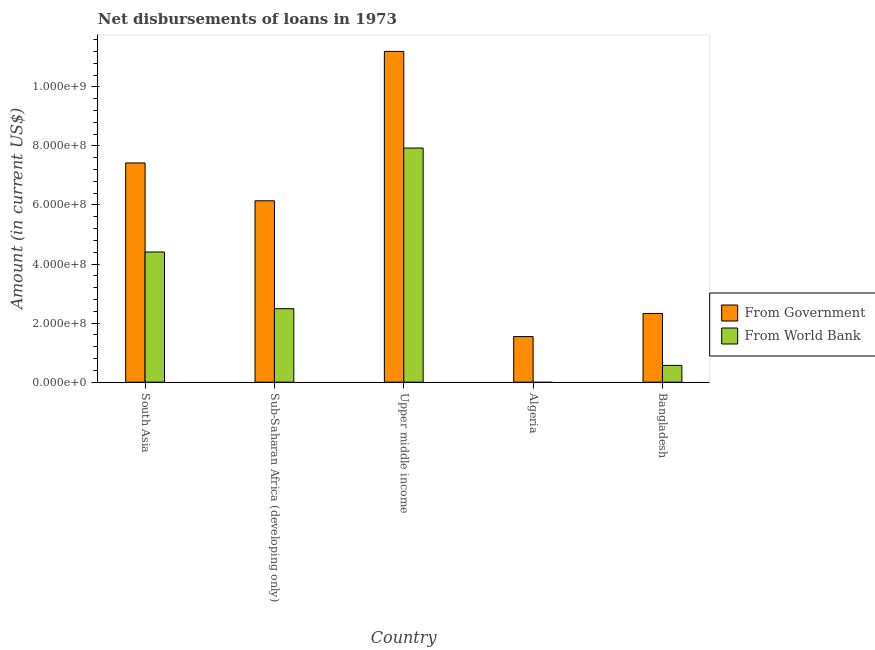How many bars are there on the 2nd tick from the left?
Make the answer very short. 2. What is the label of the 2nd group of bars from the left?
Provide a succinct answer. Sub-Saharan Africa (developing only). In how many cases, is the number of bars for a given country not equal to the number of legend labels?
Offer a very short reply. 1. What is the net disbursements of loan from government in Algeria?
Provide a succinct answer. 1.54e+08. Across all countries, what is the maximum net disbursements of loan from government?
Provide a short and direct response. 1.12e+09. Across all countries, what is the minimum net disbursements of loan from government?
Your response must be concise. 1.54e+08. In which country was the net disbursements of loan from world bank maximum?
Provide a succinct answer. Upper middle income. What is the total net disbursements of loan from world bank in the graph?
Make the answer very short. 1.54e+09. What is the difference between the net disbursements of loan from world bank in Bangladesh and that in Sub-Saharan Africa (developing only)?
Offer a very short reply. -1.92e+08. What is the difference between the net disbursements of loan from world bank in Sub-Saharan Africa (developing only) and the net disbursements of loan from government in Upper middle income?
Your answer should be compact. -8.71e+08. What is the average net disbursements of loan from world bank per country?
Ensure brevity in your answer.  3.08e+08. What is the difference between the net disbursements of loan from world bank and net disbursements of loan from government in South Asia?
Your answer should be compact. -3.02e+08. In how many countries, is the net disbursements of loan from world bank greater than 400000000 US$?
Your response must be concise. 2. What is the ratio of the net disbursements of loan from government in Bangladesh to that in Upper middle income?
Provide a succinct answer. 0.21. Is the net disbursements of loan from world bank in South Asia less than that in Sub-Saharan Africa (developing only)?
Ensure brevity in your answer.  No. Is the difference between the net disbursements of loan from world bank in Bangladesh and South Asia greater than the difference between the net disbursements of loan from government in Bangladesh and South Asia?
Your answer should be compact. Yes. What is the difference between the highest and the second highest net disbursements of loan from world bank?
Offer a very short reply. 3.52e+08. What is the difference between the highest and the lowest net disbursements of loan from world bank?
Provide a short and direct response. 7.93e+08. What is the difference between two consecutive major ticks on the Y-axis?
Give a very brief answer. 2.00e+08. Are the values on the major ticks of Y-axis written in scientific E-notation?
Your response must be concise. Yes. Does the graph contain any zero values?
Give a very brief answer. Yes. Does the graph contain grids?
Give a very brief answer. No. Where does the legend appear in the graph?
Your response must be concise. Center right. How many legend labels are there?
Give a very brief answer. 2. What is the title of the graph?
Keep it short and to the point. Net disbursements of loans in 1973. Does "National Tourists" appear as one of the legend labels in the graph?
Your response must be concise. No. What is the label or title of the X-axis?
Your answer should be compact. Country. What is the label or title of the Y-axis?
Offer a terse response. Amount (in current US$). What is the Amount (in current US$) of From Government in South Asia?
Your response must be concise. 7.42e+08. What is the Amount (in current US$) of From World Bank in South Asia?
Provide a succinct answer. 4.41e+08. What is the Amount (in current US$) of From Government in Sub-Saharan Africa (developing only)?
Ensure brevity in your answer.  6.14e+08. What is the Amount (in current US$) in From World Bank in Sub-Saharan Africa (developing only)?
Your response must be concise. 2.49e+08. What is the Amount (in current US$) in From Government in Upper middle income?
Offer a very short reply. 1.12e+09. What is the Amount (in current US$) of From World Bank in Upper middle income?
Offer a very short reply. 7.93e+08. What is the Amount (in current US$) of From Government in Algeria?
Your answer should be compact. 1.54e+08. What is the Amount (in current US$) in From Government in Bangladesh?
Your answer should be very brief. 2.33e+08. What is the Amount (in current US$) of From World Bank in Bangladesh?
Provide a short and direct response. 5.68e+07. Across all countries, what is the maximum Amount (in current US$) of From Government?
Your answer should be very brief. 1.12e+09. Across all countries, what is the maximum Amount (in current US$) in From World Bank?
Keep it short and to the point. 7.93e+08. Across all countries, what is the minimum Amount (in current US$) of From Government?
Your answer should be compact. 1.54e+08. What is the total Amount (in current US$) in From Government in the graph?
Your answer should be very brief. 2.86e+09. What is the total Amount (in current US$) of From World Bank in the graph?
Offer a very short reply. 1.54e+09. What is the difference between the Amount (in current US$) in From Government in South Asia and that in Sub-Saharan Africa (developing only)?
Your answer should be compact. 1.28e+08. What is the difference between the Amount (in current US$) of From World Bank in South Asia and that in Sub-Saharan Africa (developing only)?
Give a very brief answer. 1.92e+08. What is the difference between the Amount (in current US$) of From Government in South Asia and that in Upper middle income?
Your answer should be compact. -3.78e+08. What is the difference between the Amount (in current US$) in From World Bank in South Asia and that in Upper middle income?
Ensure brevity in your answer.  -3.52e+08. What is the difference between the Amount (in current US$) of From Government in South Asia and that in Algeria?
Give a very brief answer. 5.88e+08. What is the difference between the Amount (in current US$) in From Government in South Asia and that in Bangladesh?
Give a very brief answer. 5.10e+08. What is the difference between the Amount (in current US$) of From World Bank in South Asia and that in Bangladesh?
Make the answer very short. 3.84e+08. What is the difference between the Amount (in current US$) in From Government in Sub-Saharan Africa (developing only) and that in Upper middle income?
Give a very brief answer. -5.06e+08. What is the difference between the Amount (in current US$) of From World Bank in Sub-Saharan Africa (developing only) and that in Upper middle income?
Make the answer very short. -5.44e+08. What is the difference between the Amount (in current US$) in From Government in Sub-Saharan Africa (developing only) and that in Algeria?
Make the answer very short. 4.60e+08. What is the difference between the Amount (in current US$) of From Government in Sub-Saharan Africa (developing only) and that in Bangladesh?
Make the answer very short. 3.82e+08. What is the difference between the Amount (in current US$) of From World Bank in Sub-Saharan Africa (developing only) and that in Bangladesh?
Your answer should be compact. 1.92e+08. What is the difference between the Amount (in current US$) of From Government in Upper middle income and that in Algeria?
Your response must be concise. 9.66e+08. What is the difference between the Amount (in current US$) of From Government in Upper middle income and that in Bangladesh?
Ensure brevity in your answer.  8.87e+08. What is the difference between the Amount (in current US$) of From World Bank in Upper middle income and that in Bangladesh?
Provide a short and direct response. 7.36e+08. What is the difference between the Amount (in current US$) in From Government in Algeria and that in Bangladesh?
Offer a very short reply. -7.82e+07. What is the difference between the Amount (in current US$) of From Government in South Asia and the Amount (in current US$) of From World Bank in Sub-Saharan Africa (developing only)?
Provide a short and direct response. 4.93e+08. What is the difference between the Amount (in current US$) in From Government in South Asia and the Amount (in current US$) in From World Bank in Upper middle income?
Your answer should be very brief. -5.05e+07. What is the difference between the Amount (in current US$) in From Government in South Asia and the Amount (in current US$) in From World Bank in Bangladesh?
Provide a short and direct response. 6.85e+08. What is the difference between the Amount (in current US$) of From Government in Sub-Saharan Africa (developing only) and the Amount (in current US$) of From World Bank in Upper middle income?
Offer a terse response. -1.79e+08. What is the difference between the Amount (in current US$) in From Government in Sub-Saharan Africa (developing only) and the Amount (in current US$) in From World Bank in Bangladesh?
Provide a short and direct response. 5.57e+08. What is the difference between the Amount (in current US$) in From Government in Upper middle income and the Amount (in current US$) in From World Bank in Bangladesh?
Your response must be concise. 1.06e+09. What is the difference between the Amount (in current US$) in From Government in Algeria and the Amount (in current US$) in From World Bank in Bangladesh?
Your answer should be compact. 9.75e+07. What is the average Amount (in current US$) in From Government per country?
Offer a very short reply. 5.73e+08. What is the average Amount (in current US$) of From World Bank per country?
Keep it short and to the point. 3.08e+08. What is the difference between the Amount (in current US$) of From Government and Amount (in current US$) of From World Bank in South Asia?
Make the answer very short. 3.02e+08. What is the difference between the Amount (in current US$) of From Government and Amount (in current US$) of From World Bank in Sub-Saharan Africa (developing only)?
Keep it short and to the point. 3.65e+08. What is the difference between the Amount (in current US$) of From Government and Amount (in current US$) of From World Bank in Upper middle income?
Your answer should be compact. 3.27e+08. What is the difference between the Amount (in current US$) in From Government and Amount (in current US$) in From World Bank in Bangladesh?
Keep it short and to the point. 1.76e+08. What is the ratio of the Amount (in current US$) of From Government in South Asia to that in Sub-Saharan Africa (developing only)?
Ensure brevity in your answer.  1.21. What is the ratio of the Amount (in current US$) in From World Bank in South Asia to that in Sub-Saharan Africa (developing only)?
Offer a terse response. 1.77. What is the ratio of the Amount (in current US$) of From Government in South Asia to that in Upper middle income?
Provide a succinct answer. 0.66. What is the ratio of the Amount (in current US$) in From World Bank in South Asia to that in Upper middle income?
Your answer should be compact. 0.56. What is the ratio of the Amount (in current US$) in From Government in South Asia to that in Algeria?
Offer a very short reply. 4.81. What is the ratio of the Amount (in current US$) in From Government in South Asia to that in Bangladesh?
Give a very brief answer. 3.19. What is the ratio of the Amount (in current US$) in From World Bank in South Asia to that in Bangladesh?
Provide a succinct answer. 7.76. What is the ratio of the Amount (in current US$) of From Government in Sub-Saharan Africa (developing only) to that in Upper middle income?
Give a very brief answer. 0.55. What is the ratio of the Amount (in current US$) in From World Bank in Sub-Saharan Africa (developing only) to that in Upper middle income?
Make the answer very short. 0.31. What is the ratio of the Amount (in current US$) in From Government in Sub-Saharan Africa (developing only) to that in Algeria?
Offer a terse response. 3.98. What is the ratio of the Amount (in current US$) in From Government in Sub-Saharan Africa (developing only) to that in Bangladesh?
Offer a terse response. 2.64. What is the ratio of the Amount (in current US$) in From World Bank in Sub-Saharan Africa (developing only) to that in Bangladesh?
Offer a very short reply. 4.38. What is the ratio of the Amount (in current US$) in From Government in Upper middle income to that in Algeria?
Provide a short and direct response. 7.26. What is the ratio of the Amount (in current US$) of From Government in Upper middle income to that in Bangladesh?
Make the answer very short. 4.82. What is the ratio of the Amount (in current US$) in From World Bank in Upper middle income to that in Bangladesh?
Your response must be concise. 13.96. What is the ratio of the Amount (in current US$) of From Government in Algeria to that in Bangladesh?
Give a very brief answer. 0.66. What is the difference between the highest and the second highest Amount (in current US$) of From Government?
Ensure brevity in your answer.  3.78e+08. What is the difference between the highest and the second highest Amount (in current US$) of From World Bank?
Ensure brevity in your answer.  3.52e+08. What is the difference between the highest and the lowest Amount (in current US$) of From Government?
Your answer should be compact. 9.66e+08. What is the difference between the highest and the lowest Amount (in current US$) of From World Bank?
Make the answer very short. 7.93e+08. 